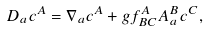<formula> <loc_0><loc_0><loc_500><loc_500>D _ { a } c ^ { A } = \nabla _ { a } c ^ { A } + g f ^ { A } _ { B C } A _ { a } ^ { B } c ^ { C } ,</formula> 